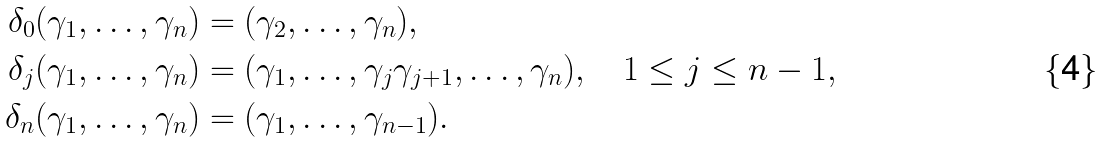<formula> <loc_0><loc_0><loc_500><loc_500>\delta _ { 0 } ( \gamma _ { 1 } , \dots , \gamma _ { n } ) & = ( \gamma _ { 2 } , \dots , \gamma _ { n } ) , \\ \delta _ { j } ( \gamma _ { 1 } , \dots , \gamma _ { n } ) & = ( \gamma _ { 1 } , \dots , \gamma _ { j } \gamma _ { j + 1 } , \dots , \gamma _ { n } ) , \quad 1 \leq j \leq n - 1 , \\ \delta _ { n } ( \gamma _ { 1 } , \dots , \gamma _ { n } ) & = ( \gamma _ { 1 } , \dots , \gamma _ { n - 1 } ) .</formula> 